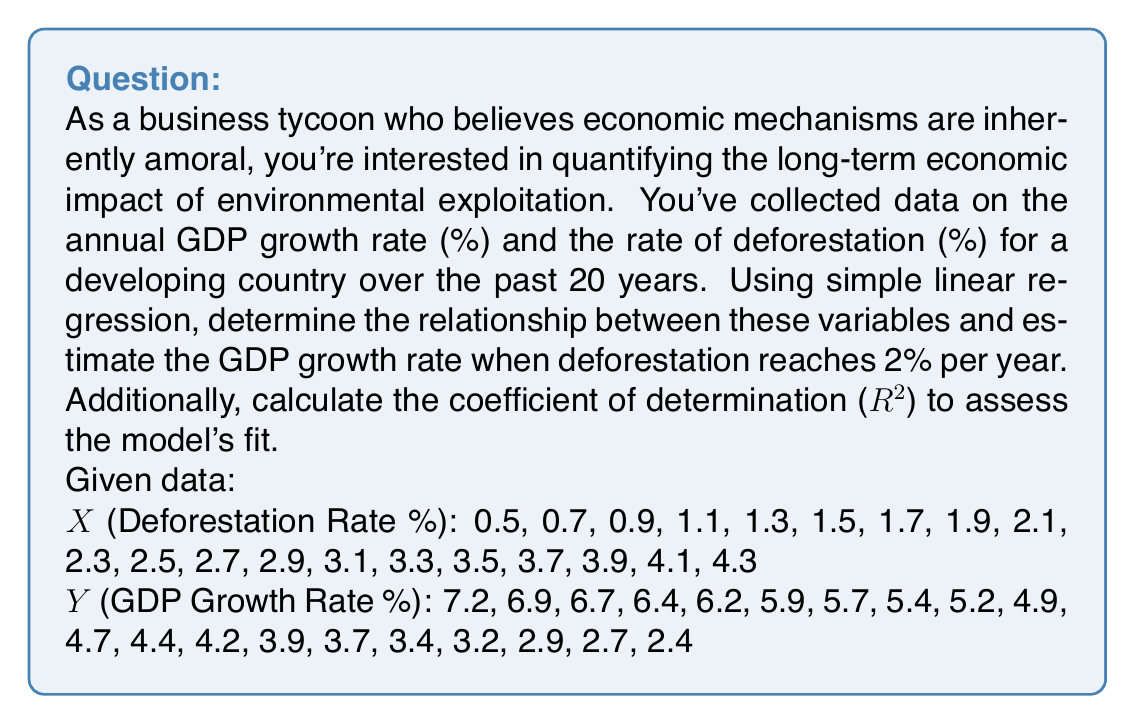Provide a solution to this math problem. To solve this problem, we'll use simple linear regression and follow these steps:

1. Calculate the means of $X$ and $Y$:
   $$\bar{X} = \frac{\sum X_i}{n} = 2.4$$
   $$\bar{Y} = \frac{\sum Y_i}{n} = 4.85$$

2. Calculate the slope ($b$) of the regression line:
   $$b = \frac{\sum(X_i - \bar{X})(Y_i - \bar{Y})}{\sum(X_i - \bar{X})^2}$$
   
   After calculations: $b = -1.25$

3. Calculate the y-intercept ($a$):
   $$a = \bar{Y} - b\bar{X}$$
   
   $a = 4.85 - (-1.25 \times 2.4) = 7.85$

4. The regression equation is:
   $$Y = 7.85 - 1.25X$$

5. To estimate the GDP growth rate when deforestation is 2%, substitute $X = 2$ into the equation:
   $$Y = 7.85 - 1.25(2) = 5.35$$

6. Calculate the coefficient of determination ($R^2$):
   $$R^2 = \frac{(\sum(X_i - \bar{X})(Y_i - \bar{Y}))^2}{\sum(X_i - \bar{X})^2 \sum(Y_i - \bar{Y})^2}$$
   
   After calculations: $R^2 = 0.9998$

The high $R^2$ value indicates that the model explains 99.98% of the variability in the data, suggesting a very strong fit.
Answer: The estimated GDP growth rate when deforestation reaches 2% per year is 5.35%. The regression equation is $Y = 7.85 - 1.25X$, where $X$ is the deforestation rate and $Y$ is the GDP growth rate. The coefficient of determination ($R^2$) is 0.9998, indicating a very strong fit of the model to the data. 